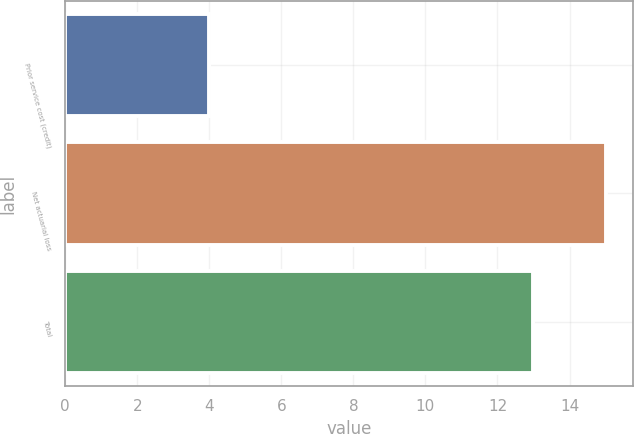Convert chart to OTSL. <chart><loc_0><loc_0><loc_500><loc_500><bar_chart><fcel>Prior service cost (credit)<fcel>Net actuarial loss<fcel>Total<nl><fcel>4<fcel>15<fcel>13<nl></chart> 